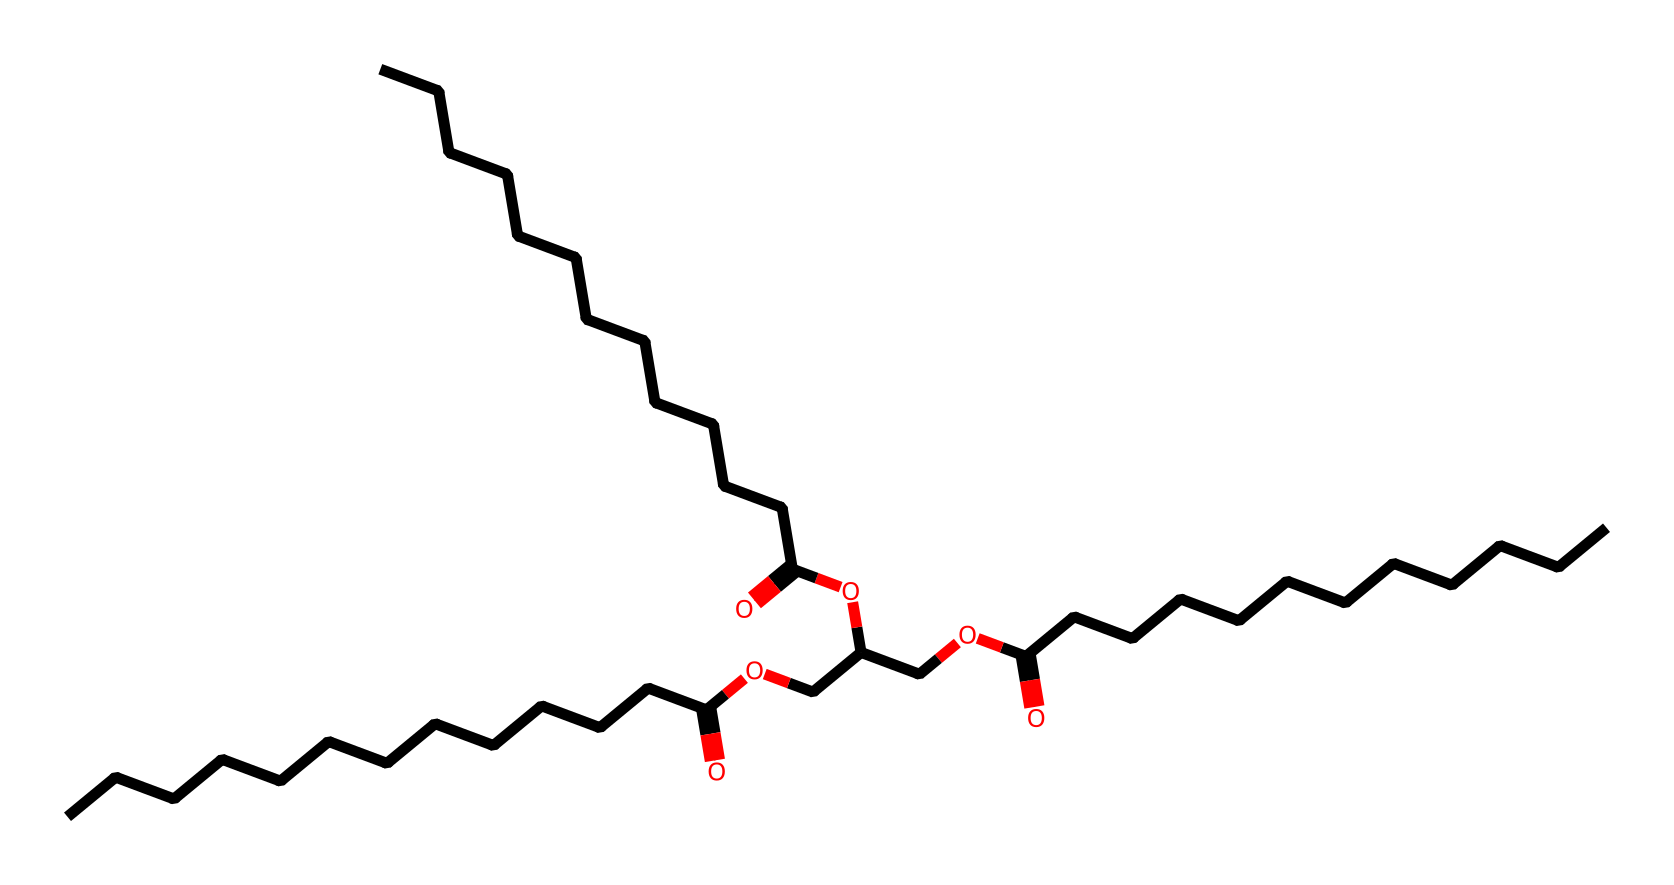What is the main functional group present in this chemical? The presence of the -COOH (carboxylic acid) group indicates that this chemical has carboxylic acid functional groups. This can be observed from the structure where there are multiple -COOH segments in the SMILES representation.
Answer: carboxylic acid How many carbon atoms are in the longest chain of this structure? By analyzing the SMILES string, we can see multiple carbon chains connected; the longest continuous chain has 12 carbon atoms, evident from the sequence of connected “C” characters in the representation.
Answer: 12 What is the total number of oxygen atoms in this chemical? In the SMILES representation, there are three instances of the carbonyl group (=O) and four instances of the ether (-O-) and carboxylic acid (O) groupings. When counted together, this sums up to a total of seven oxygen atoms.
Answer: 7 Is this compound likely to be polar or nonpolar based on its structure? The presence of multiple polar functional groups like carboxylic acids and ethers creates a tendency for this compound to be polar. The overall structure contains both hydrophilic parts (functional groups) and hydrophobic parts (long carbon chains), but the polar groups dominate.
Answer: polar Does this chemical likely pose any health hazards based on its functional groups? The presence of carboxylic acids typically indicate that the chemical may cause skin irritation. Additionally, chemicals with long carbon chains can be irritants or harmful, suggesting that this compound could pose health hazards.
Answer: yes What type of solvent is primarily indicated by this chemical structure? Given the carboxylic acids and ether linkages, this chemical is characteristic of a solvent used for dissolving organic substances and likely functions as an emulsifier in the context of makeup remover solvents.
Answer: organic solvent 